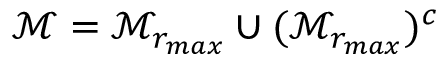Convert formula to latex. <formula><loc_0><loc_0><loc_500><loc_500>\mathcal { M } = \mathcal { M } _ { r _ { \max } } \cup ( \mathcal { M } _ { r _ { \max } } ) ^ { c }</formula> 